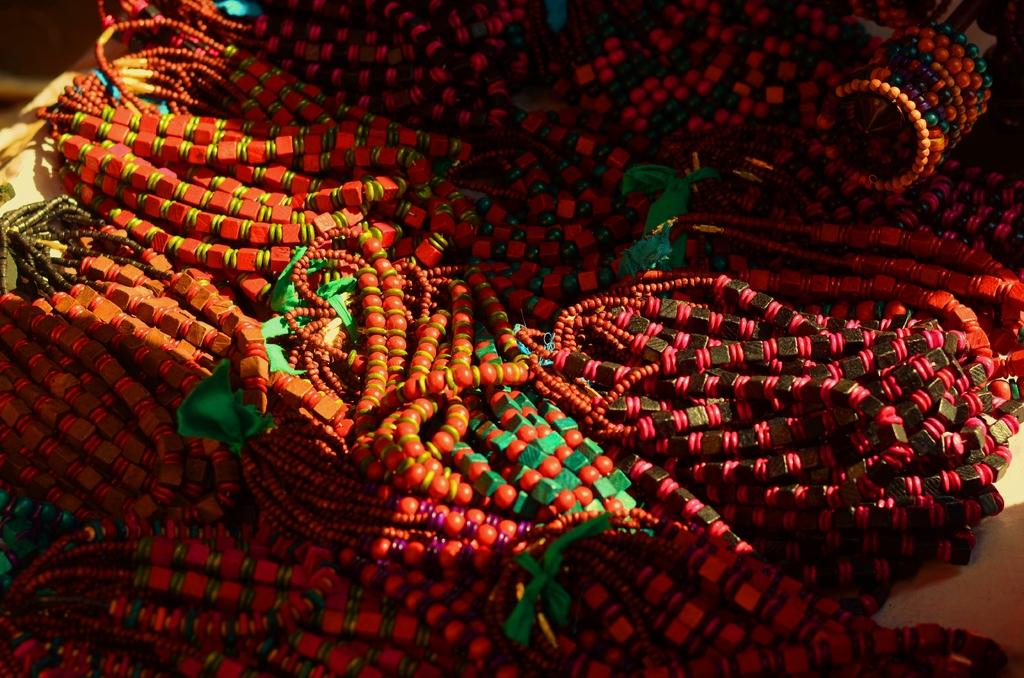What type of accessory is featured in the picture? There is wrist wear in the picture. What colors can be seen on the wrist wear? The wrist wear has green, black, red, and orange colors. How does the wrist wear generate a wave in the image? There is no wave generated by the wrist wear in the image. The wrist wear is an accessory with specific colors, and there is no indication of any wave-generating capability. 